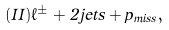Convert formula to latex. <formula><loc_0><loc_0><loc_500><loc_500>( I I ) \ell ^ { \pm } + 2 j e t s + p _ { m i s s } ,</formula> 